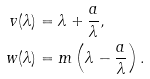<formula> <loc_0><loc_0><loc_500><loc_500>v ( \lambda ) & = \lambda + \frac { a } { \lambda } , \\ w ( \lambda ) & = m \left ( \lambda - \frac { a } { \lambda } \right ) .</formula> 